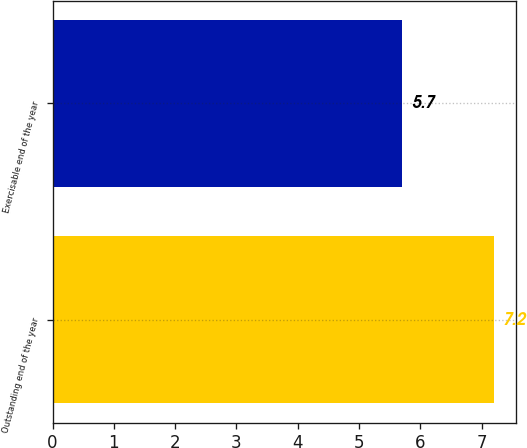Convert chart. <chart><loc_0><loc_0><loc_500><loc_500><bar_chart><fcel>Outstanding end of the year<fcel>Exercisable end of the year<nl><fcel>7.2<fcel>5.7<nl></chart> 